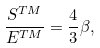Convert formula to latex. <formula><loc_0><loc_0><loc_500><loc_500>\frac { S ^ { T M } } { E ^ { T M } } = \frac { 4 } { 3 } \beta ,</formula> 